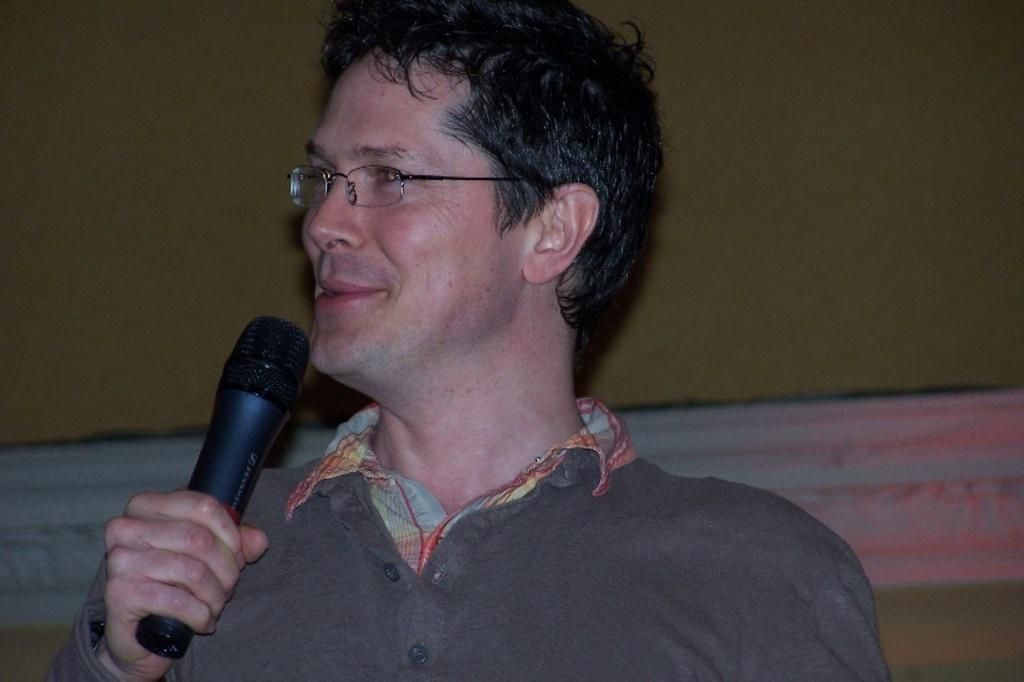What is the main subject of the image? There is a person in the image. What is the person holding in the image? The person is holding a microphone (mike). What can be seen behind the person in the image? There is a wall behind the person. What type of development can be seen taking place in the image? There is no development taking place in the image; it features a person holding a microphone with a wall in the background. 